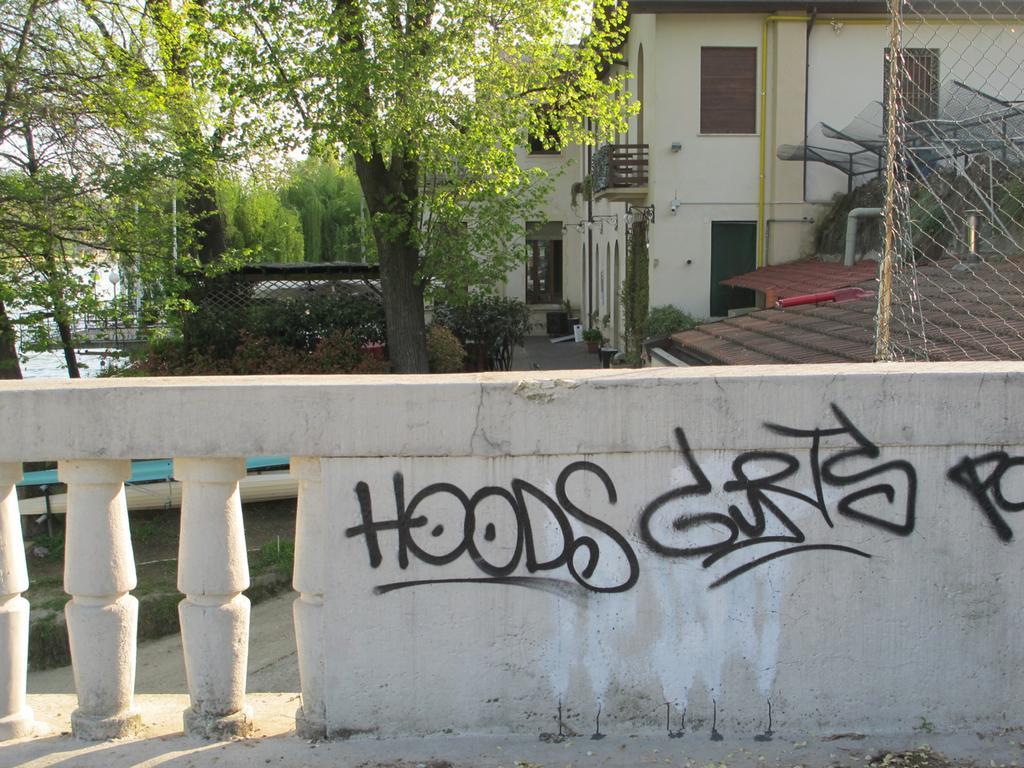What is located at the bottom of the image? There is a wall at the bottom of the image. What is written or displayed on the wall? There is text on the wall. What type of structures can be seen in the image? There are buildings visible in the image. What type of vegetation is present in the image? There are trees in the image. What type of barrier is visible in the image? There is a fence in the image. What is the rate of the crowd moving in the image? There is no crowd present in the image, so it is not possible to determine the rate at which they might be moving. 